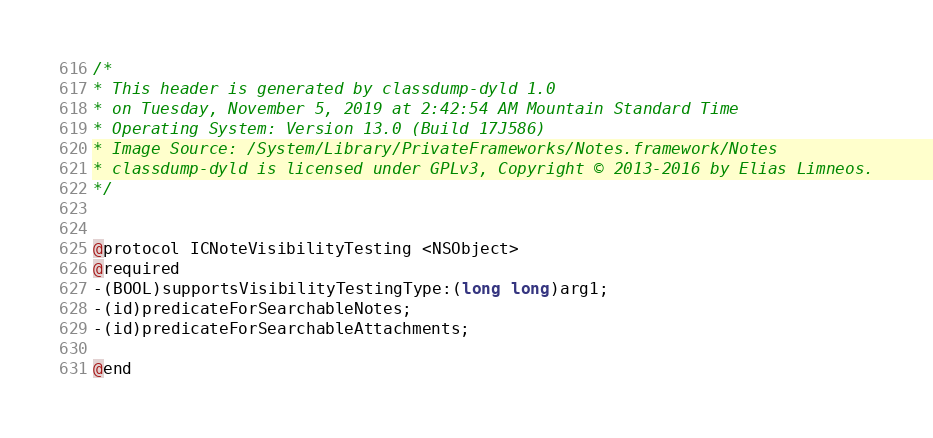Convert code to text. <code><loc_0><loc_0><loc_500><loc_500><_C_>/*
* This header is generated by classdump-dyld 1.0
* on Tuesday, November 5, 2019 at 2:42:54 AM Mountain Standard Time
* Operating System: Version 13.0 (Build 17J586)
* Image Source: /System/Library/PrivateFrameworks/Notes.framework/Notes
* classdump-dyld is licensed under GPLv3, Copyright © 2013-2016 by Elias Limneos.
*/


@protocol ICNoteVisibilityTesting <NSObject>
@required
-(BOOL)supportsVisibilityTestingType:(long long)arg1;
-(id)predicateForSearchableNotes;
-(id)predicateForSearchableAttachments;

@end

</code> 